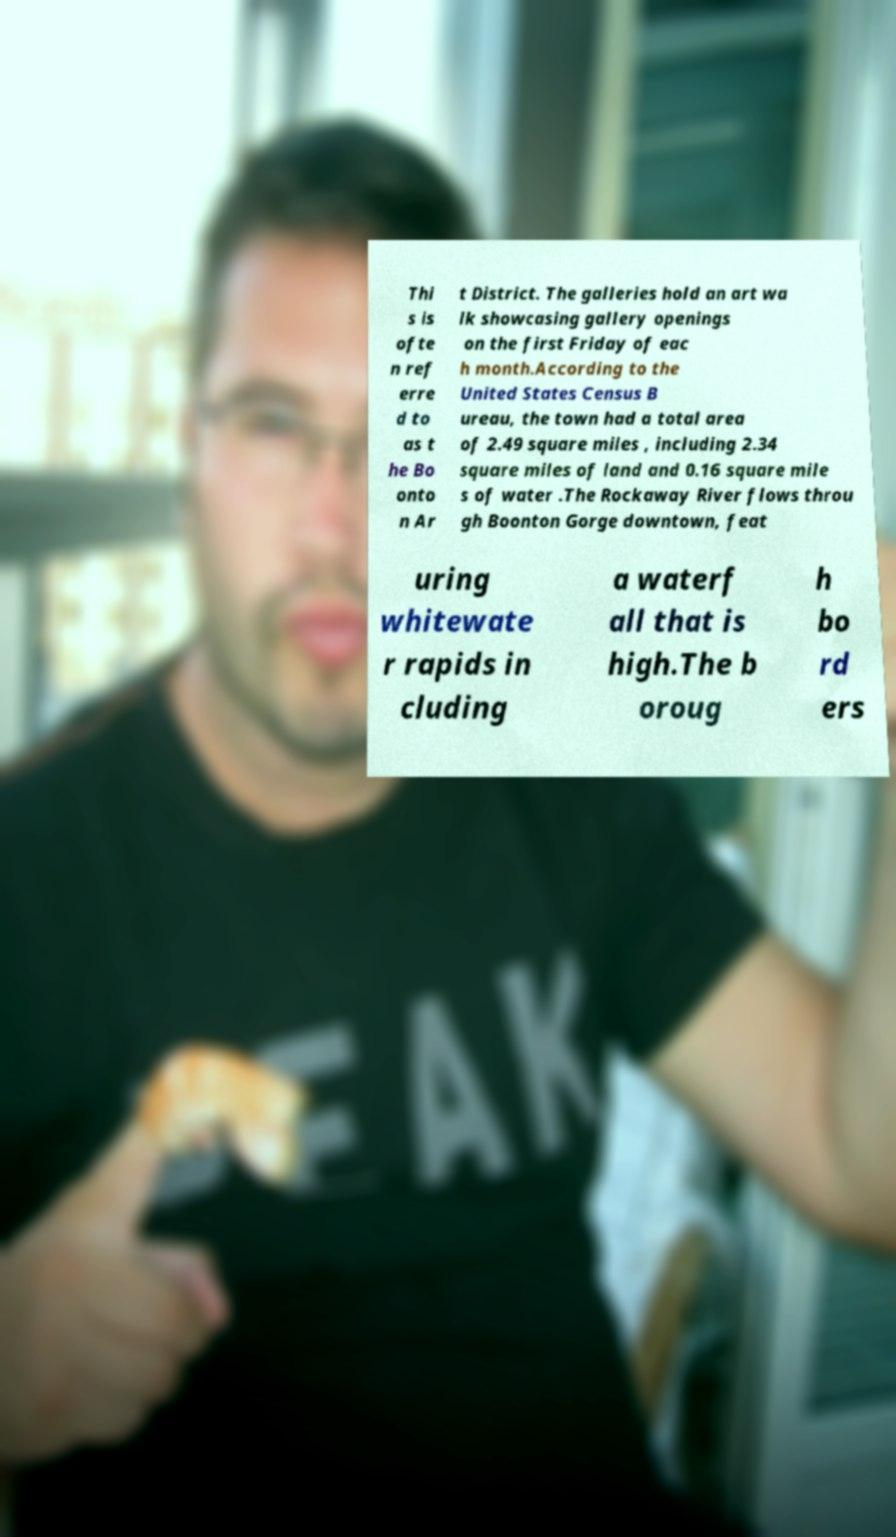Could you extract and type out the text from this image? Thi s is ofte n ref erre d to as t he Bo onto n Ar t District. The galleries hold an art wa lk showcasing gallery openings on the first Friday of eac h month.According to the United States Census B ureau, the town had a total area of 2.49 square miles , including 2.34 square miles of land and 0.16 square mile s of water .The Rockaway River flows throu gh Boonton Gorge downtown, feat uring whitewate r rapids in cluding a waterf all that is high.The b oroug h bo rd ers 